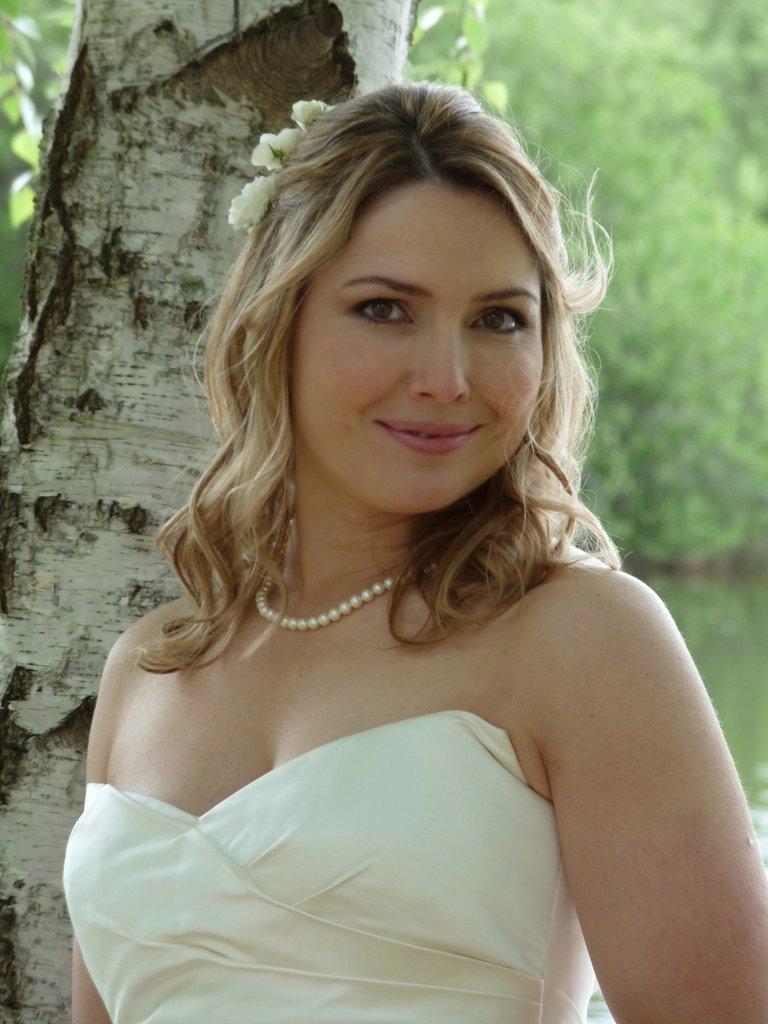Can you describe this image briefly? In this image I can see the person and the person is wearing white color dress. Background I can see the trees in green color. 